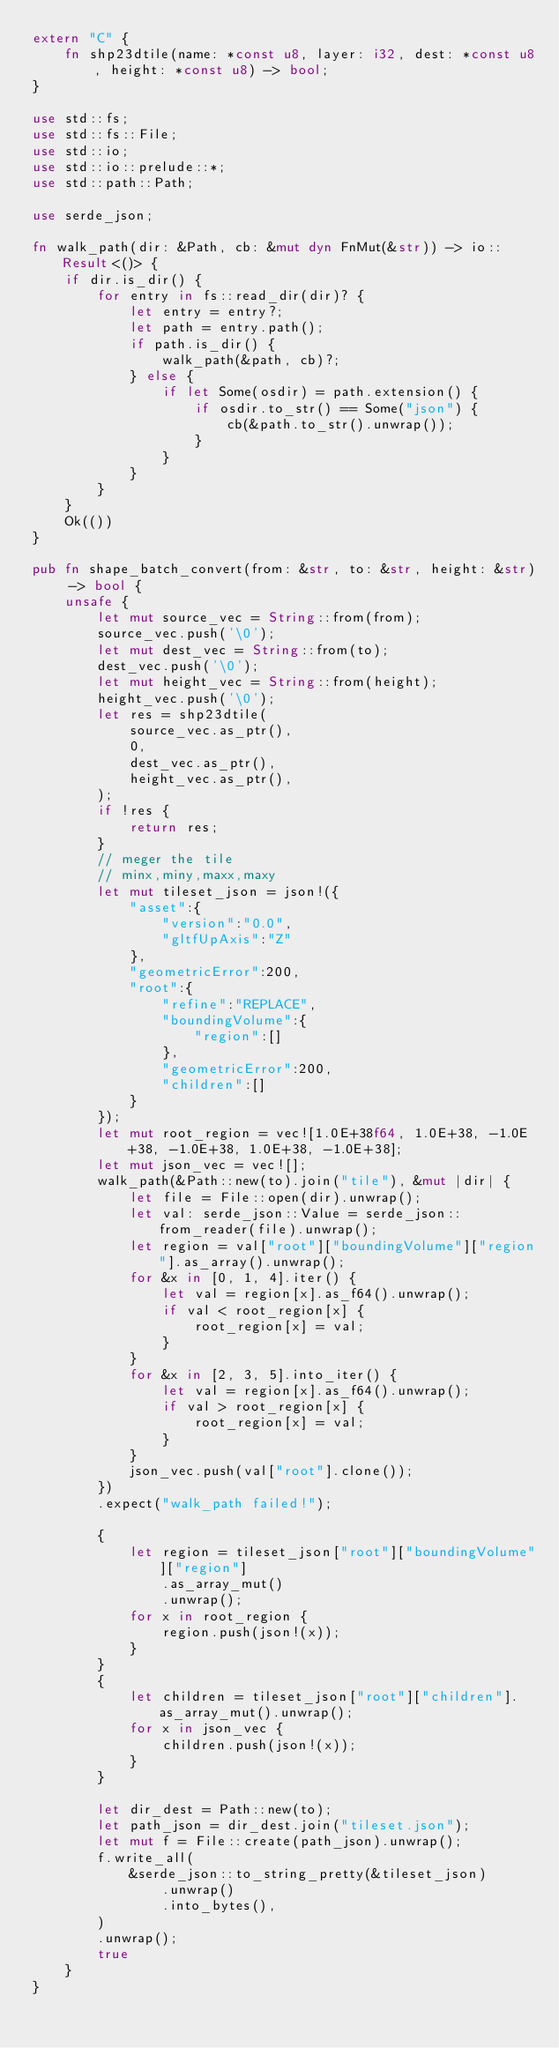<code> <loc_0><loc_0><loc_500><loc_500><_Rust_>extern "C" {
    fn shp23dtile(name: *const u8, layer: i32, dest: *const u8, height: *const u8) -> bool;
}

use std::fs;
use std::fs::File;
use std::io;
use std::io::prelude::*;
use std::path::Path;

use serde_json;

fn walk_path(dir: &Path, cb: &mut dyn FnMut(&str)) -> io::Result<()> {
    if dir.is_dir() {
        for entry in fs::read_dir(dir)? {
            let entry = entry?;
            let path = entry.path();
            if path.is_dir() {
                walk_path(&path, cb)?;
            } else {
                if let Some(osdir) = path.extension() {
                    if osdir.to_str() == Some("json") {
                        cb(&path.to_str().unwrap());
                    }
                }
            }
        }
    }
    Ok(())
}

pub fn shape_batch_convert(from: &str, to: &str, height: &str) -> bool {
    unsafe {
        let mut source_vec = String::from(from);
        source_vec.push('\0');
        let mut dest_vec = String::from(to);
        dest_vec.push('\0');
        let mut height_vec = String::from(height);
        height_vec.push('\0');
        let res = shp23dtile(
            source_vec.as_ptr(),
            0,
            dest_vec.as_ptr(),
            height_vec.as_ptr(),
        );
        if !res {
            return res;
        }
        // meger the tile
        // minx,miny,maxx,maxy
        let mut tileset_json = json!({
            "asset":{
                "version":"0.0",
                "gltfUpAxis":"Z"
            },
            "geometricError":200,
            "root":{
                "refine":"REPLACE",
                "boundingVolume":{
                    "region":[]
                },
                "geometricError":200,
                "children":[]
            }
        });
        let mut root_region = vec![1.0E+38f64, 1.0E+38, -1.0E+38, -1.0E+38, 1.0E+38, -1.0E+38];
        let mut json_vec = vec![];
        walk_path(&Path::new(to).join("tile"), &mut |dir| {
            let file = File::open(dir).unwrap();
            let val: serde_json::Value = serde_json::from_reader(file).unwrap();
            let region = val["root"]["boundingVolume"]["region"].as_array().unwrap();
            for &x in [0, 1, 4].iter() {
                let val = region[x].as_f64().unwrap();
                if val < root_region[x] {
                    root_region[x] = val;
                }
            }
            for &x in [2, 3, 5].into_iter() {
                let val = region[x].as_f64().unwrap();
                if val > root_region[x] {
                    root_region[x] = val;
                }
            }
            json_vec.push(val["root"].clone());
        })
        .expect("walk_path failed!");

        {
            let region = tileset_json["root"]["boundingVolume"]["region"]
                .as_array_mut()
                .unwrap();
            for x in root_region {
                region.push(json!(x));
            }
        }
        {
            let children = tileset_json["root"]["children"].as_array_mut().unwrap();
            for x in json_vec {
                children.push(json!(x));
            }
        }

        let dir_dest = Path::new(to);
        let path_json = dir_dest.join("tileset.json");
        let mut f = File::create(path_json).unwrap();
        f.write_all(
            &serde_json::to_string_pretty(&tileset_json)
                .unwrap()
                .into_bytes(),
        )
        .unwrap();
        true
    }
}
</code> 